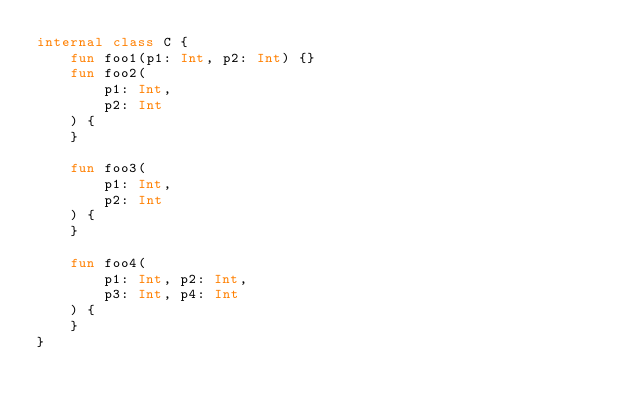Convert code to text. <code><loc_0><loc_0><loc_500><loc_500><_Kotlin_>internal class C {
    fun foo1(p1: Int, p2: Int) {}
    fun foo2(
        p1: Int,
        p2: Int
    ) {
    }

    fun foo3(
        p1: Int,
        p2: Int
    ) {
    }

    fun foo4(
        p1: Int, p2: Int,
        p3: Int, p4: Int
    ) {
    }
}</code> 